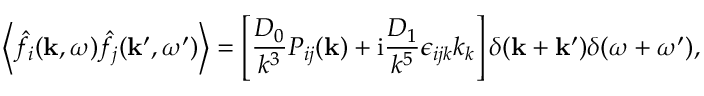Convert formula to latex. <formula><loc_0><loc_0><loc_500><loc_500>\left \langle \hat { f } _ { i } ( k , \omega ) \hat { f } _ { j } ( k ^ { \prime } , \omega ^ { \prime } ) \right \rangle = \left [ \frac { D _ { 0 } } { k ^ { 3 } } P _ { i j } ( k ) + i \frac { D _ { 1 } } { k ^ { 5 } } \epsilon _ { i j k } k _ { k } \right ] \delta ( k + k ^ { \prime } ) \delta ( \omega + \omega ^ { \prime } ) ,</formula> 